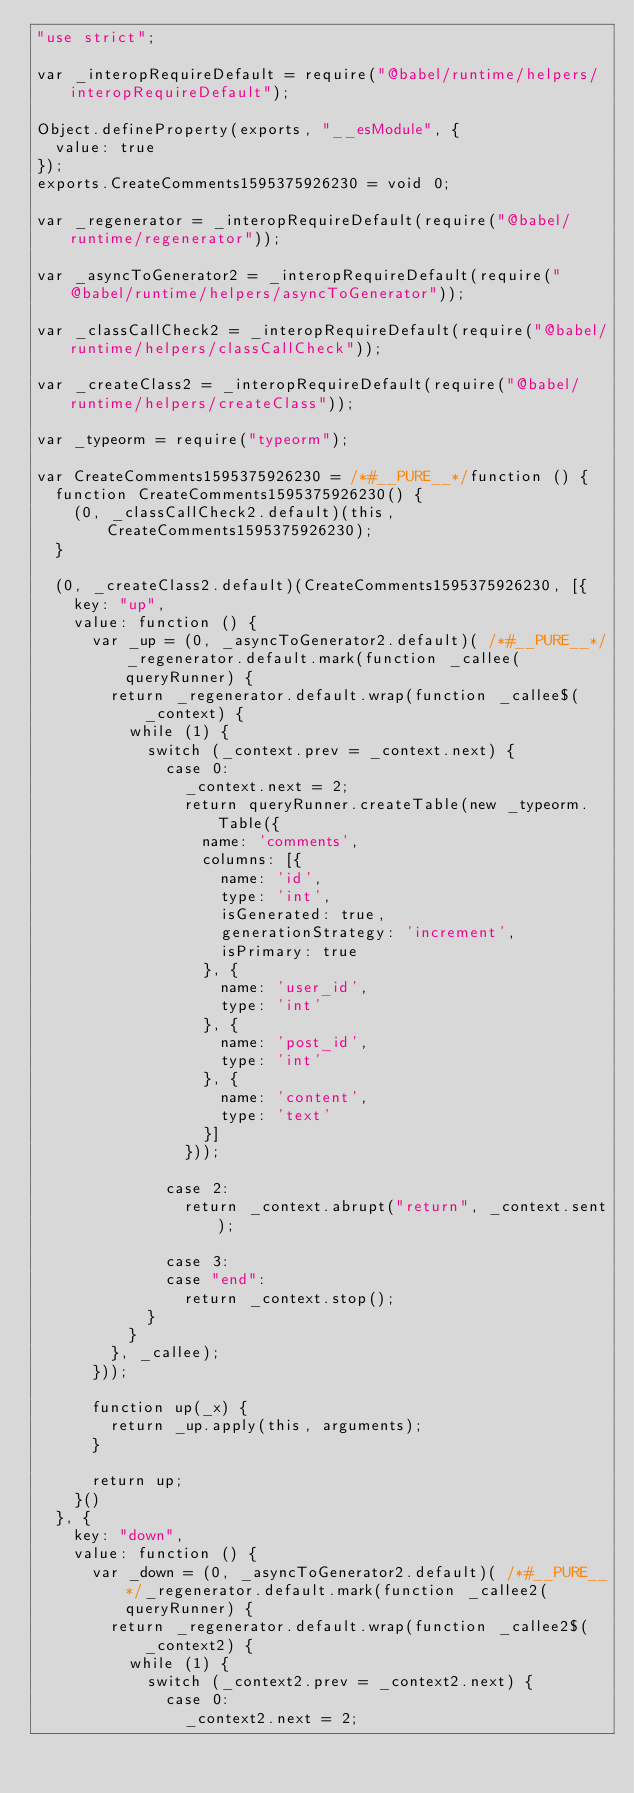Convert code to text. <code><loc_0><loc_0><loc_500><loc_500><_JavaScript_>"use strict";

var _interopRequireDefault = require("@babel/runtime/helpers/interopRequireDefault");

Object.defineProperty(exports, "__esModule", {
  value: true
});
exports.CreateComments1595375926230 = void 0;

var _regenerator = _interopRequireDefault(require("@babel/runtime/regenerator"));

var _asyncToGenerator2 = _interopRequireDefault(require("@babel/runtime/helpers/asyncToGenerator"));

var _classCallCheck2 = _interopRequireDefault(require("@babel/runtime/helpers/classCallCheck"));

var _createClass2 = _interopRequireDefault(require("@babel/runtime/helpers/createClass"));

var _typeorm = require("typeorm");

var CreateComments1595375926230 = /*#__PURE__*/function () {
  function CreateComments1595375926230() {
    (0, _classCallCheck2.default)(this, CreateComments1595375926230);
  }

  (0, _createClass2.default)(CreateComments1595375926230, [{
    key: "up",
    value: function () {
      var _up = (0, _asyncToGenerator2.default)( /*#__PURE__*/_regenerator.default.mark(function _callee(queryRunner) {
        return _regenerator.default.wrap(function _callee$(_context) {
          while (1) {
            switch (_context.prev = _context.next) {
              case 0:
                _context.next = 2;
                return queryRunner.createTable(new _typeorm.Table({
                  name: 'comments',
                  columns: [{
                    name: 'id',
                    type: 'int',
                    isGenerated: true,
                    generationStrategy: 'increment',
                    isPrimary: true
                  }, {
                    name: 'user_id',
                    type: 'int'
                  }, {
                    name: 'post_id',
                    type: 'int'
                  }, {
                    name: 'content',
                    type: 'text'
                  }]
                }));

              case 2:
                return _context.abrupt("return", _context.sent);

              case 3:
              case "end":
                return _context.stop();
            }
          }
        }, _callee);
      }));

      function up(_x) {
        return _up.apply(this, arguments);
      }

      return up;
    }()
  }, {
    key: "down",
    value: function () {
      var _down = (0, _asyncToGenerator2.default)( /*#__PURE__*/_regenerator.default.mark(function _callee2(queryRunner) {
        return _regenerator.default.wrap(function _callee2$(_context2) {
          while (1) {
            switch (_context2.prev = _context2.next) {
              case 0:
                _context2.next = 2;</code> 